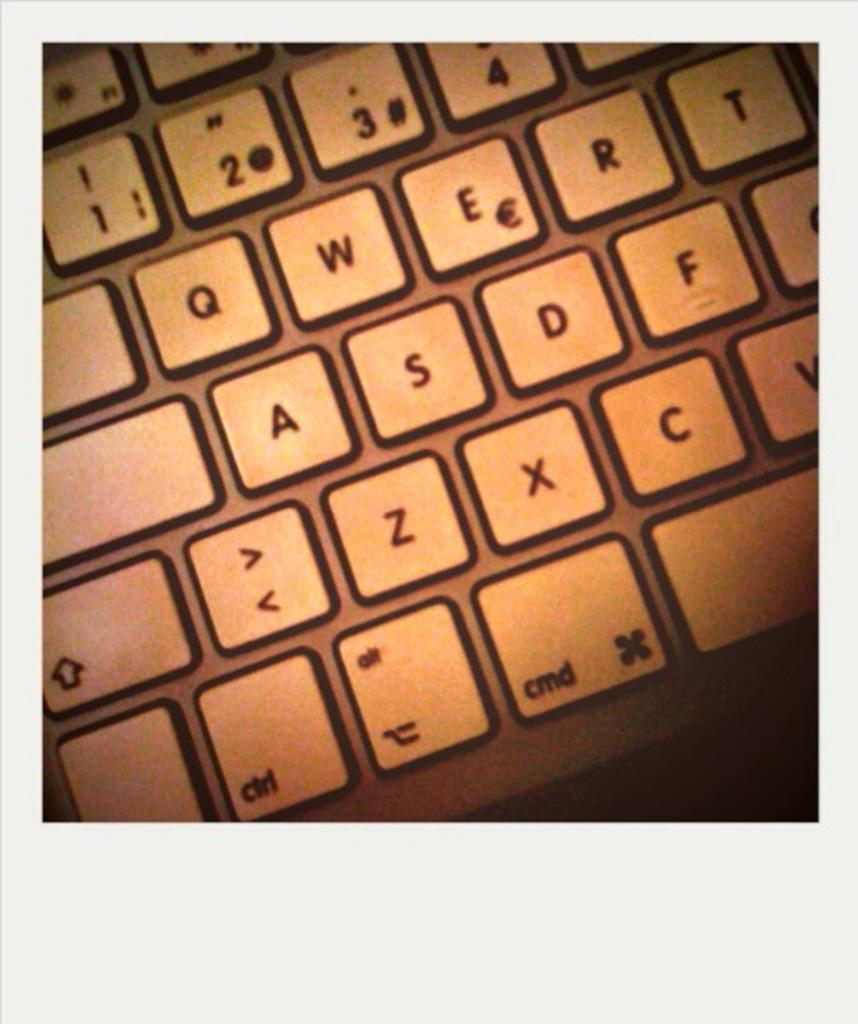<image>
Write a terse but informative summary of the picture. a white keyboard that shows the letters 'a' 's' and 'd' on it 